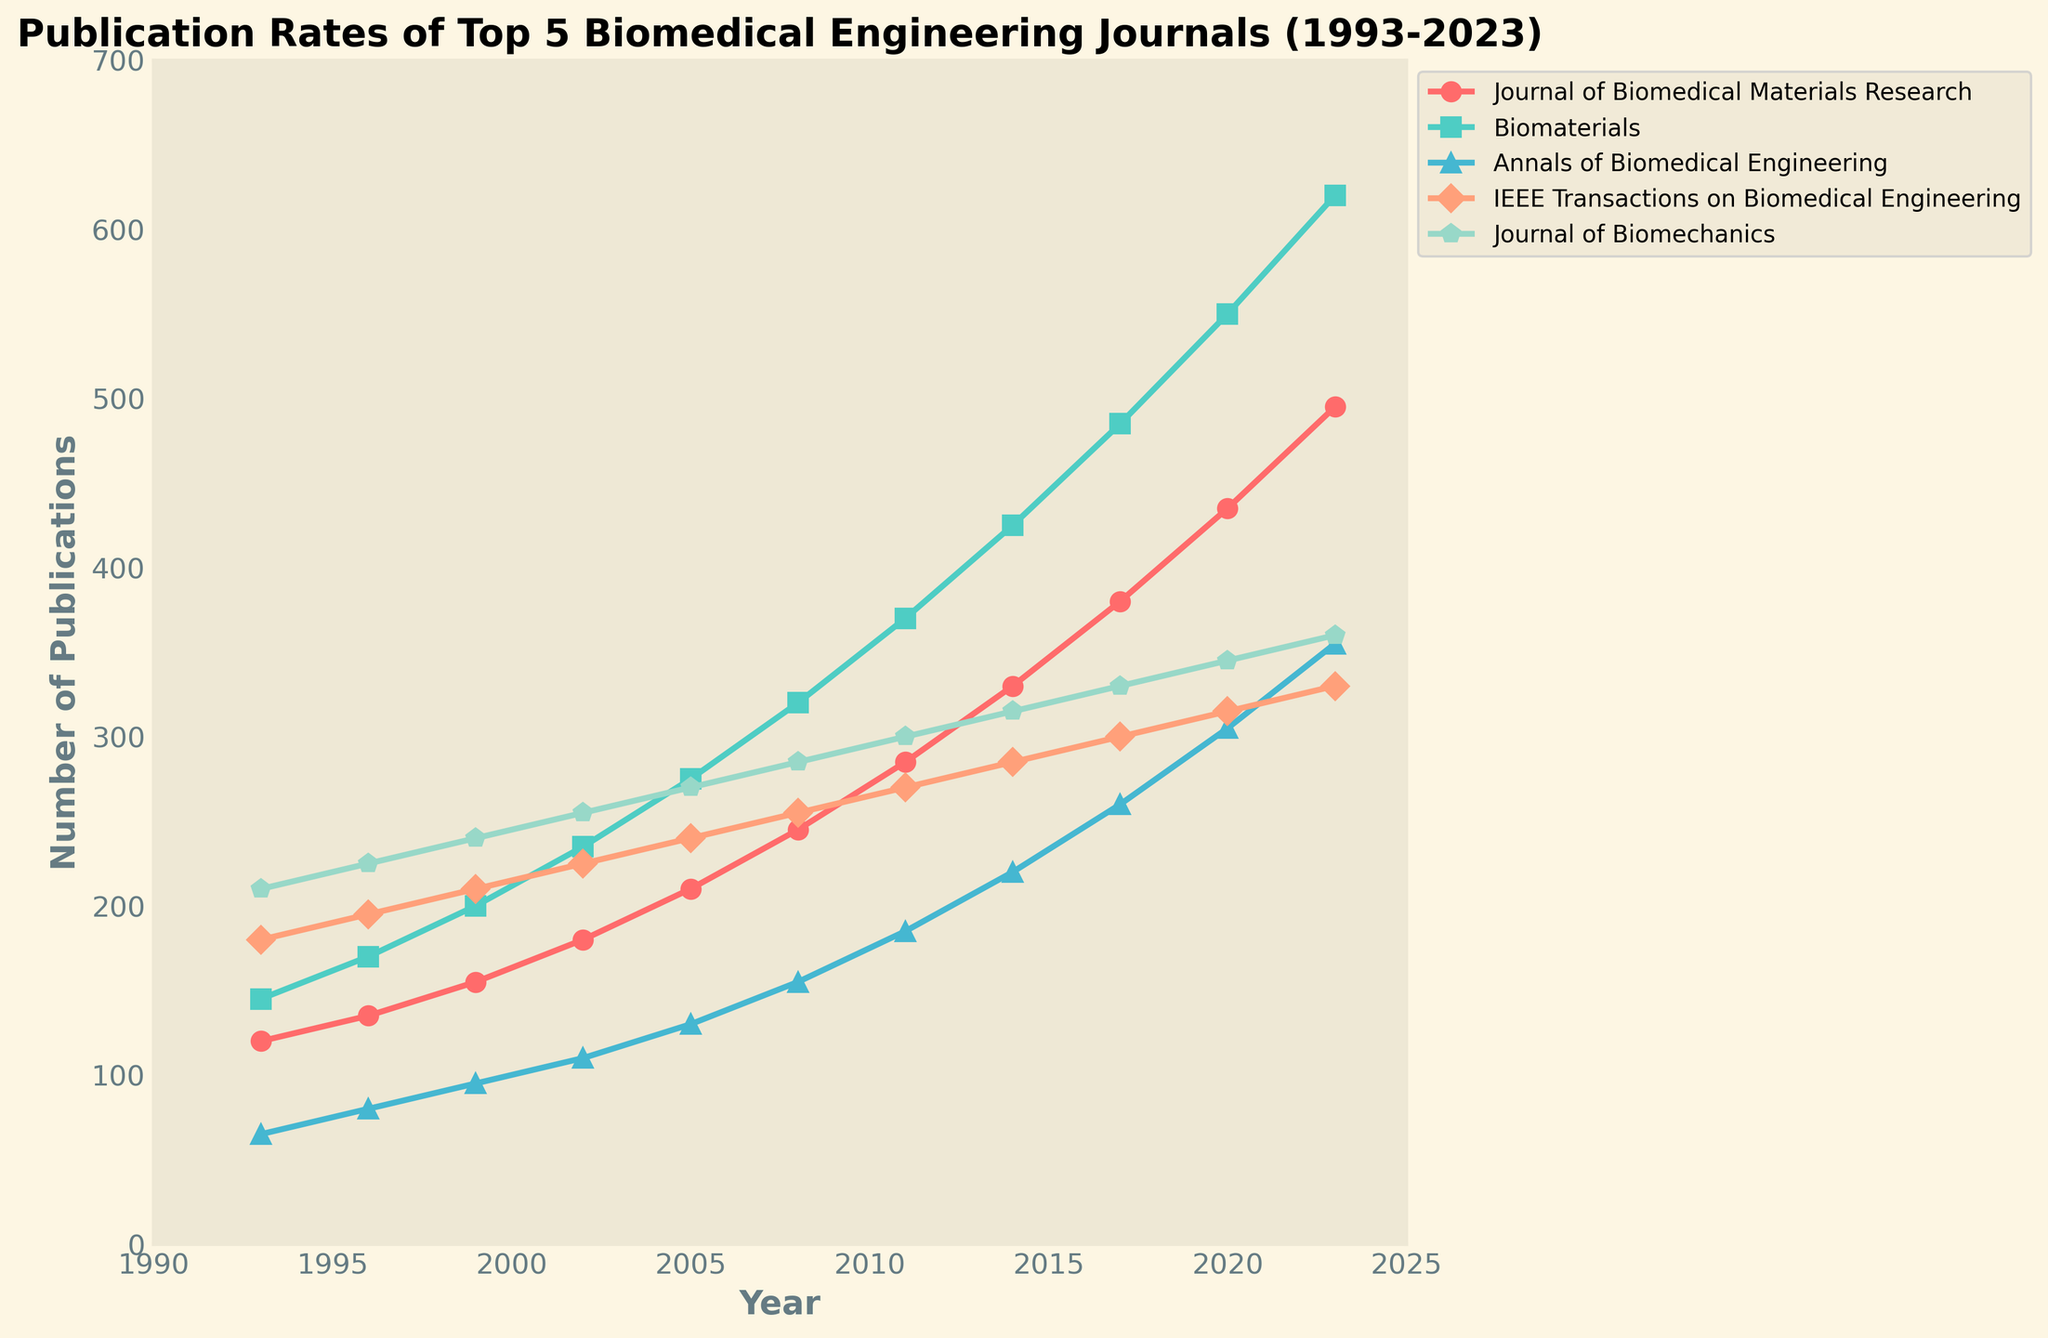What is the publication trend for the Journal of Biomedical Materials Research from 1993 to 2023? Starting with 120 publications in 1993, the Journal of Biomedical Materials Research shows a steady increase in publication numbers over 30 years, reaching 495 publications by 2023. The trend indicates consistent growth.
Answer: Steady increase In which year did Biomaterials surpass 400 publications? Biomaterials surpassed 400 publications in the year 2014. By examining the graph, the publication rate crosses the 400 mark between 2011 and 2014, indicating the exact year as 2014.
Answer: 2014 Which journal had the most significant publication increase between 2017 and 2020? Biomaterials experienced the most significant increase, growing from 485 publications in 2017 to 550 in 2020, a rise of 65 publications. Other journals increased at slower rates.
Answer: Biomaterials How does the number of publications in the IEEE Transactions on Biomedical Engineering in 1993 compare to the number in 2023? In 1993, the IEEE Transactions on Biomedical Engineering had 180 publications, which increased to 330 by 2023. This shows an increase of 150 publications over 30 years.
Answer: Increased by 150 What is the visual difference in data markers between the Annals of Biomedical Engineering and the Journal of Biomechanics? The Annals of Biomedical Engineering uses triangle-shaped (^) markers, while the Journal of Biomechanics uses pentagon-shaped (p) markers, making them visually distinguishable.
Answer: Triangle and pentagon Which journal had the smallest publication increase from 2014 to 2017? IEEE Transactions on Biomedical Engineering increased from 285 publications in 2014 to 300 in 2017, an increase of 15, the smallest among the five journals.
Answer: IEEE Transactions on Biomedical Engineering What's the average number of publications for Biomaterials across the years provided? Summing up the publications for Biomaterials (145+170+200+235+275+320+370+425+485+550+620) gives a total of 3795. Dividing by 11 (number of years) results in an average of approximately 345 publications.
Answer: ~345 Which journal showed a plateau in publication growth around the year 2020? IEEE Transactions on Biomedical Engineering shows a relatively flat growth between 2017 (300 publications) and 2023 (330 publications), indicating a plateau in publication rates around 2020.
Answer: IEEE Transactions on Biomedical Engineering 